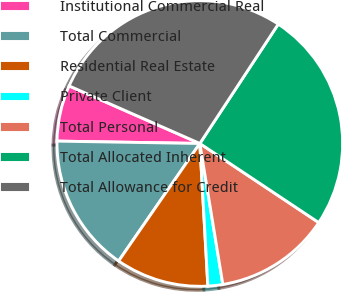Convert chart to OTSL. <chart><loc_0><loc_0><loc_500><loc_500><pie_chart><fcel>Institutional Commercial Real<fcel>Total Commercial<fcel>Residential Real Estate<fcel>Private Client<fcel>Total Personal<fcel>Total Allocated Inherent<fcel>Total Allowance for Credit<nl><fcel>6.34%<fcel>15.64%<fcel>10.52%<fcel>1.68%<fcel>13.08%<fcel>25.09%<fcel>27.65%<nl></chart> 